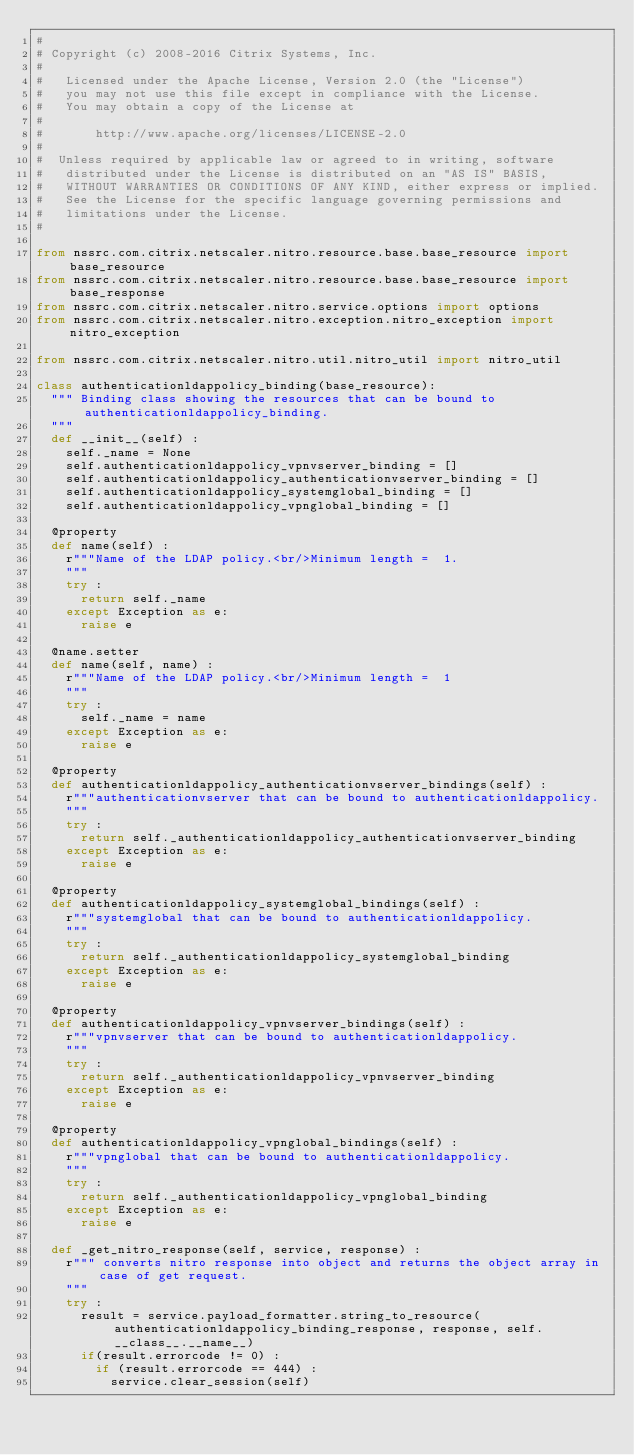Convert code to text. <code><loc_0><loc_0><loc_500><loc_500><_Python_>#
# Copyright (c) 2008-2016 Citrix Systems, Inc.
#
#   Licensed under the Apache License, Version 2.0 (the "License")
#   you may not use this file except in compliance with the License.
#   You may obtain a copy of the License at
#
#       http://www.apache.org/licenses/LICENSE-2.0
#
#  Unless required by applicable law or agreed to in writing, software
#   distributed under the License is distributed on an "AS IS" BASIS,
#   WITHOUT WARRANTIES OR CONDITIONS OF ANY KIND, either express or implied.
#   See the License for the specific language governing permissions and
#   limitations under the License.
#

from nssrc.com.citrix.netscaler.nitro.resource.base.base_resource import base_resource
from nssrc.com.citrix.netscaler.nitro.resource.base.base_resource import base_response
from nssrc.com.citrix.netscaler.nitro.service.options import options
from nssrc.com.citrix.netscaler.nitro.exception.nitro_exception import nitro_exception

from nssrc.com.citrix.netscaler.nitro.util.nitro_util import nitro_util

class authenticationldappolicy_binding(base_resource):
	""" Binding class showing the resources that can be bound to authenticationldappolicy_binding. 
	"""
	def __init__(self) :
		self._name = None
		self.authenticationldappolicy_vpnvserver_binding = []
		self.authenticationldappolicy_authenticationvserver_binding = []
		self.authenticationldappolicy_systemglobal_binding = []
		self.authenticationldappolicy_vpnglobal_binding = []

	@property
	def name(self) :
		r"""Name of the LDAP policy.<br/>Minimum length =  1.
		"""
		try :
			return self._name
		except Exception as e:
			raise e

	@name.setter
	def name(self, name) :
		r"""Name of the LDAP policy.<br/>Minimum length =  1
		"""
		try :
			self._name = name
		except Exception as e:
			raise e

	@property
	def authenticationldappolicy_authenticationvserver_bindings(self) :
		r"""authenticationvserver that can be bound to authenticationldappolicy.
		"""
		try :
			return self._authenticationldappolicy_authenticationvserver_binding
		except Exception as e:
			raise e

	@property
	def authenticationldappolicy_systemglobal_bindings(self) :
		r"""systemglobal that can be bound to authenticationldappolicy.
		"""
		try :
			return self._authenticationldappolicy_systemglobal_binding
		except Exception as e:
			raise e

	@property
	def authenticationldappolicy_vpnvserver_bindings(self) :
		r"""vpnvserver that can be bound to authenticationldappolicy.
		"""
		try :
			return self._authenticationldappolicy_vpnvserver_binding
		except Exception as e:
			raise e

	@property
	def authenticationldappolicy_vpnglobal_bindings(self) :
		r"""vpnglobal that can be bound to authenticationldappolicy.
		"""
		try :
			return self._authenticationldappolicy_vpnglobal_binding
		except Exception as e:
			raise e

	def _get_nitro_response(self, service, response) :
		r""" converts nitro response into object and returns the object array in case of get request.
		"""
		try :
			result = service.payload_formatter.string_to_resource(authenticationldappolicy_binding_response, response, self.__class__.__name__)
			if(result.errorcode != 0) :
				if (result.errorcode == 444) :
					service.clear_session(self)</code> 